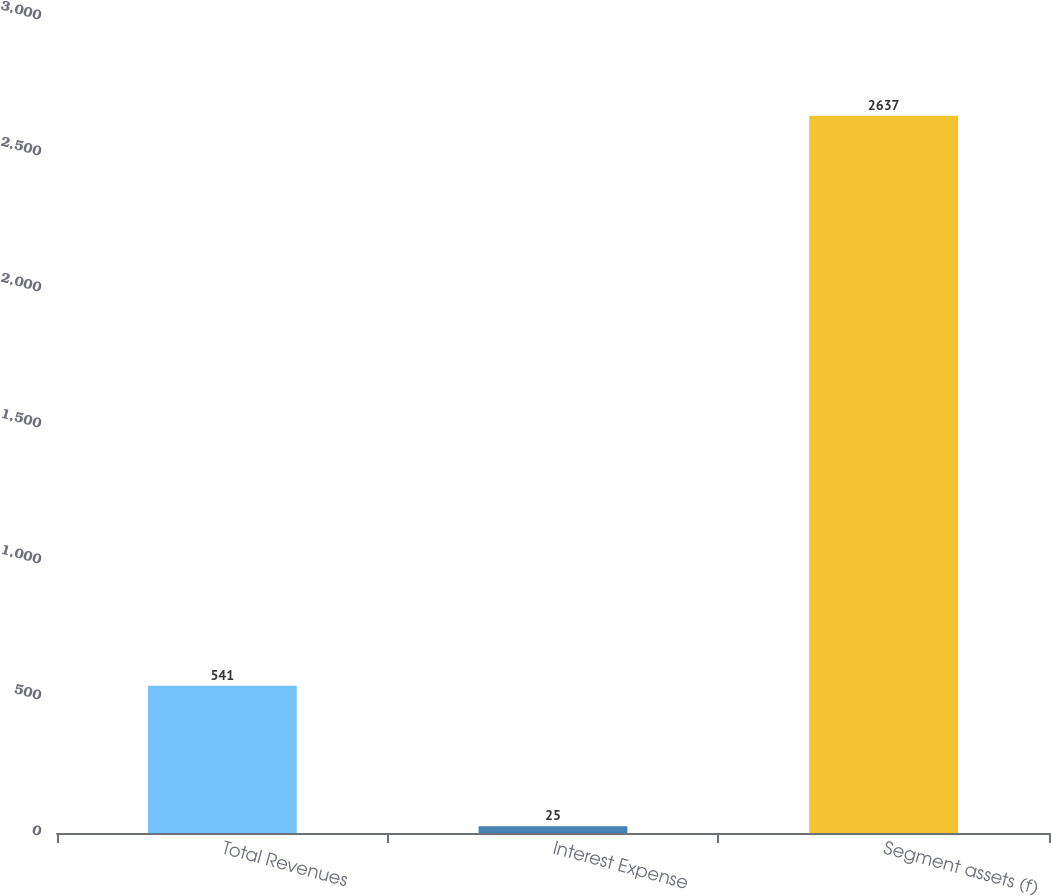Convert chart to OTSL. <chart><loc_0><loc_0><loc_500><loc_500><bar_chart><fcel>Total Revenues<fcel>Interest Expense<fcel>Segment assets (f)<nl><fcel>541<fcel>25<fcel>2637<nl></chart> 